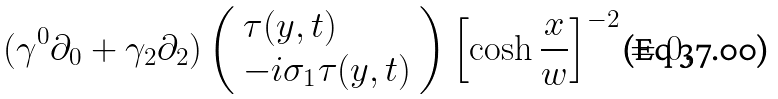<formula> <loc_0><loc_0><loc_500><loc_500>( \gamma ^ { 0 } \partial _ { 0 } + \gamma _ { 2 } \partial _ { 2 } ) \left ( \begin{array} { l } \tau ( y , t ) \\ - i \sigma _ { 1 } \tau ( y , t ) \end{array} \right ) \left [ \cosh \frac { x } { w } \right ] ^ { - 2 } = 0 ,</formula> 